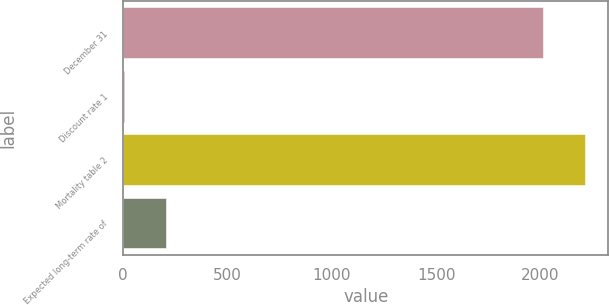Convert chart. <chart><loc_0><loc_0><loc_500><loc_500><bar_chart><fcel>December 31<fcel>Discount rate 1<fcel>Mortality table 2<fcel>Expected long-term rate of<nl><fcel>2014<fcel>4.1<fcel>2214.99<fcel>205.09<nl></chart> 